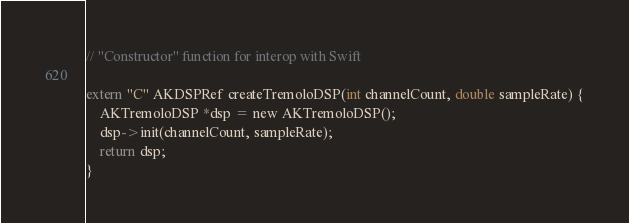Convert code to text. <code><loc_0><loc_0><loc_500><loc_500><_ObjectiveC_>// "Constructor" function for interop with Swift

extern "C" AKDSPRef createTremoloDSP(int channelCount, double sampleRate) {
    AKTremoloDSP *dsp = new AKTremoloDSP();
    dsp->init(channelCount, sampleRate);
    return dsp;
}
</code> 